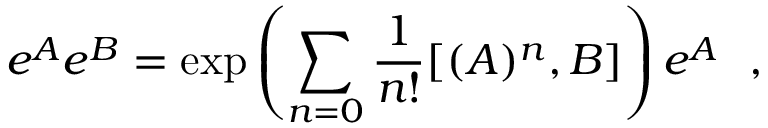<formula> <loc_0><loc_0><loc_500><loc_500>e ^ { A } e ^ { B } = \exp \left ( \sum _ { n = 0 } \frac { 1 } { n ! } [ ( A ) ^ { n } , B ] \right ) e ^ { A } ,</formula> 